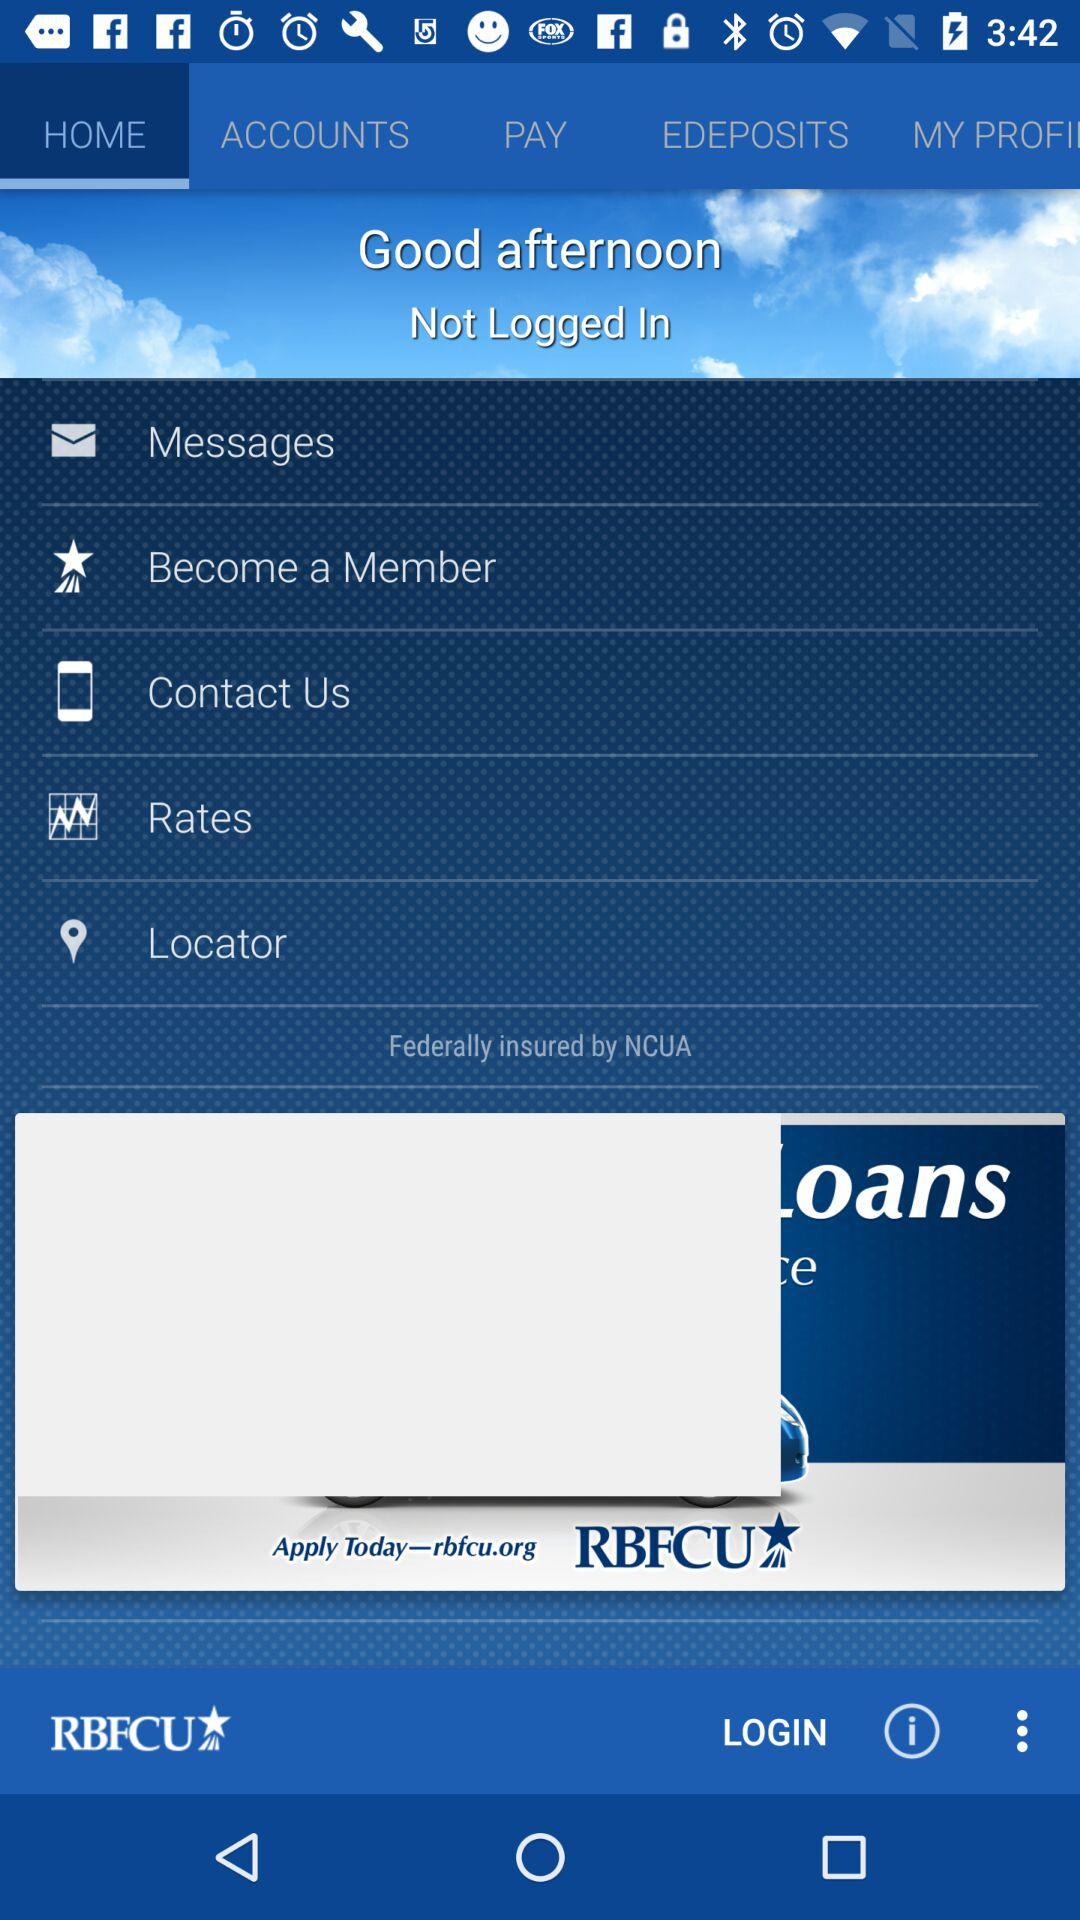Which option has been selected? The selected option is "HOME". 